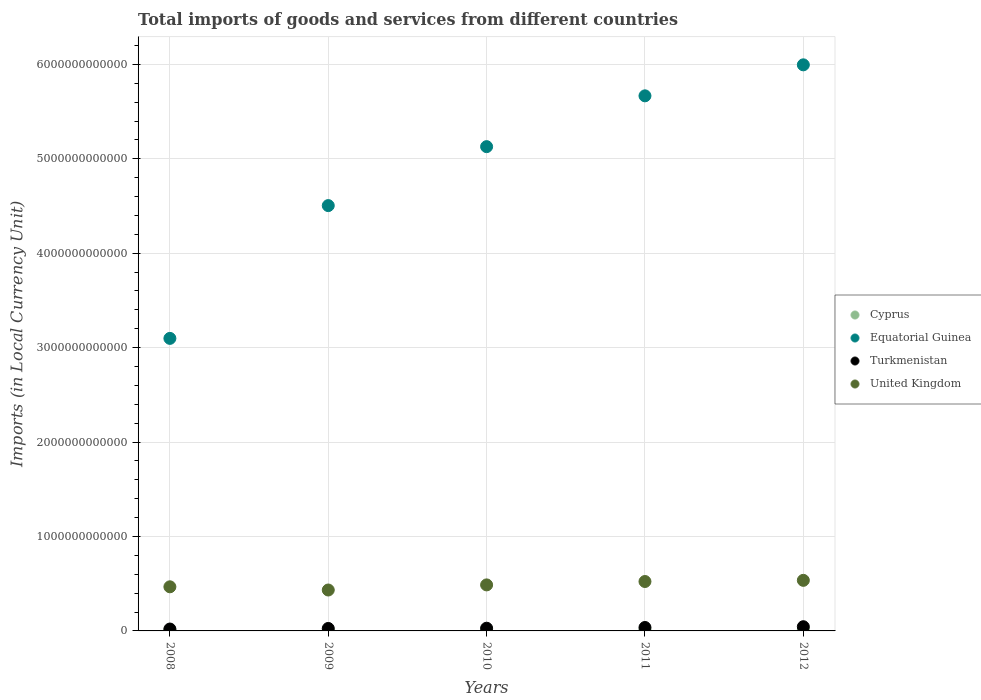What is the Amount of goods and services imports in Equatorial Guinea in 2010?
Provide a succinct answer. 5.13e+12. Across all years, what is the maximum Amount of goods and services imports in Equatorial Guinea?
Your answer should be compact. 6.00e+12. Across all years, what is the minimum Amount of goods and services imports in Cyprus?
Keep it short and to the point. 9.55e+09. In which year was the Amount of goods and services imports in Equatorial Guinea minimum?
Make the answer very short. 2008. What is the total Amount of goods and services imports in United Kingdom in the graph?
Your response must be concise. 2.45e+12. What is the difference between the Amount of goods and services imports in Cyprus in 2008 and that in 2011?
Offer a terse response. 1.12e+09. What is the difference between the Amount of goods and services imports in Equatorial Guinea in 2011 and the Amount of goods and services imports in Turkmenistan in 2012?
Make the answer very short. 5.62e+12. What is the average Amount of goods and services imports in Turkmenistan per year?
Offer a very short reply. 3.11e+1. In the year 2011, what is the difference between the Amount of goods and services imports in Equatorial Guinea and Amount of goods and services imports in United Kingdom?
Your answer should be compact. 5.14e+12. What is the ratio of the Amount of goods and services imports in Cyprus in 2008 to that in 2010?
Your response must be concise. 1.13. Is the Amount of goods and services imports in Turkmenistan in 2010 less than that in 2011?
Ensure brevity in your answer.  Yes. What is the difference between the highest and the second highest Amount of goods and services imports in Equatorial Guinea?
Your answer should be compact. 3.28e+11. What is the difference between the highest and the lowest Amount of goods and services imports in Turkmenistan?
Offer a very short reply. 2.45e+1. In how many years, is the Amount of goods and services imports in Equatorial Guinea greater than the average Amount of goods and services imports in Equatorial Guinea taken over all years?
Provide a succinct answer. 3. Is the sum of the Amount of goods and services imports in Equatorial Guinea in 2011 and 2012 greater than the maximum Amount of goods and services imports in United Kingdom across all years?
Give a very brief answer. Yes. Is it the case that in every year, the sum of the Amount of goods and services imports in Turkmenistan and Amount of goods and services imports in United Kingdom  is greater than the sum of Amount of goods and services imports in Cyprus and Amount of goods and services imports in Equatorial Guinea?
Your answer should be very brief. No. Is it the case that in every year, the sum of the Amount of goods and services imports in Cyprus and Amount of goods and services imports in Turkmenistan  is greater than the Amount of goods and services imports in United Kingdom?
Keep it short and to the point. No. Is the Amount of goods and services imports in Turkmenistan strictly greater than the Amount of goods and services imports in United Kingdom over the years?
Your answer should be very brief. No. Is the Amount of goods and services imports in Equatorial Guinea strictly less than the Amount of goods and services imports in Turkmenistan over the years?
Your answer should be compact. No. What is the difference between two consecutive major ticks on the Y-axis?
Provide a succinct answer. 1.00e+12. Where does the legend appear in the graph?
Your response must be concise. Center right. How many legend labels are there?
Provide a short and direct response. 4. What is the title of the graph?
Your response must be concise. Total imports of goods and services from different countries. Does "Ireland" appear as one of the legend labels in the graph?
Provide a short and direct response. No. What is the label or title of the Y-axis?
Offer a very short reply. Imports (in Local Currency Unit). What is the Imports (in Local Currency Unit) in Cyprus in 2008?
Give a very brief answer. 1.14e+1. What is the Imports (in Local Currency Unit) of Equatorial Guinea in 2008?
Provide a short and direct response. 3.10e+12. What is the Imports (in Local Currency Unit) of Turkmenistan in 2008?
Make the answer very short. 2.00e+1. What is the Imports (in Local Currency Unit) in United Kingdom in 2008?
Offer a terse response. 4.67e+11. What is the Imports (in Local Currency Unit) of Cyprus in 2009?
Keep it short and to the point. 9.55e+09. What is the Imports (in Local Currency Unit) in Equatorial Guinea in 2009?
Your answer should be compact. 4.50e+12. What is the Imports (in Local Currency Unit) of Turkmenistan in 2009?
Your answer should be compact. 2.61e+1. What is the Imports (in Local Currency Unit) in United Kingdom in 2009?
Make the answer very short. 4.33e+11. What is the Imports (in Local Currency Unit) of Cyprus in 2010?
Offer a very short reply. 1.02e+1. What is the Imports (in Local Currency Unit) of Equatorial Guinea in 2010?
Offer a terse response. 5.13e+12. What is the Imports (in Local Currency Unit) in Turkmenistan in 2010?
Make the answer very short. 2.86e+1. What is the Imports (in Local Currency Unit) of United Kingdom in 2010?
Your response must be concise. 4.87e+11. What is the Imports (in Local Currency Unit) of Cyprus in 2011?
Give a very brief answer. 1.03e+1. What is the Imports (in Local Currency Unit) of Equatorial Guinea in 2011?
Keep it short and to the point. 5.67e+12. What is the Imports (in Local Currency Unit) in Turkmenistan in 2011?
Offer a terse response. 3.63e+1. What is the Imports (in Local Currency Unit) of United Kingdom in 2011?
Offer a very short reply. 5.23e+11. What is the Imports (in Local Currency Unit) in Cyprus in 2012?
Make the answer very short. 1.00e+1. What is the Imports (in Local Currency Unit) of Equatorial Guinea in 2012?
Offer a very short reply. 6.00e+12. What is the Imports (in Local Currency Unit) of Turkmenistan in 2012?
Your answer should be very brief. 4.45e+1. What is the Imports (in Local Currency Unit) of United Kingdom in 2012?
Your answer should be very brief. 5.36e+11. Across all years, what is the maximum Imports (in Local Currency Unit) of Cyprus?
Give a very brief answer. 1.14e+1. Across all years, what is the maximum Imports (in Local Currency Unit) in Equatorial Guinea?
Keep it short and to the point. 6.00e+12. Across all years, what is the maximum Imports (in Local Currency Unit) of Turkmenistan?
Your answer should be compact. 4.45e+1. Across all years, what is the maximum Imports (in Local Currency Unit) in United Kingdom?
Your answer should be compact. 5.36e+11. Across all years, what is the minimum Imports (in Local Currency Unit) of Cyprus?
Provide a short and direct response. 9.55e+09. Across all years, what is the minimum Imports (in Local Currency Unit) of Equatorial Guinea?
Offer a very short reply. 3.10e+12. Across all years, what is the minimum Imports (in Local Currency Unit) of Turkmenistan?
Offer a terse response. 2.00e+1. Across all years, what is the minimum Imports (in Local Currency Unit) of United Kingdom?
Your response must be concise. 4.33e+11. What is the total Imports (in Local Currency Unit) in Cyprus in the graph?
Offer a very short reply. 5.15e+1. What is the total Imports (in Local Currency Unit) in Equatorial Guinea in the graph?
Offer a very short reply. 2.44e+13. What is the total Imports (in Local Currency Unit) of Turkmenistan in the graph?
Your answer should be very brief. 1.55e+11. What is the total Imports (in Local Currency Unit) of United Kingdom in the graph?
Ensure brevity in your answer.  2.45e+12. What is the difference between the Imports (in Local Currency Unit) in Cyprus in 2008 and that in 2009?
Provide a short and direct response. 1.89e+09. What is the difference between the Imports (in Local Currency Unit) of Equatorial Guinea in 2008 and that in 2009?
Your response must be concise. -1.41e+12. What is the difference between the Imports (in Local Currency Unit) of Turkmenistan in 2008 and that in 2009?
Your answer should be very brief. -6.09e+09. What is the difference between the Imports (in Local Currency Unit) of United Kingdom in 2008 and that in 2009?
Offer a terse response. 3.39e+1. What is the difference between the Imports (in Local Currency Unit) of Cyprus in 2008 and that in 2010?
Give a very brief answer. 1.28e+09. What is the difference between the Imports (in Local Currency Unit) in Equatorial Guinea in 2008 and that in 2010?
Your response must be concise. -2.03e+12. What is the difference between the Imports (in Local Currency Unit) of Turkmenistan in 2008 and that in 2010?
Provide a short and direct response. -8.65e+09. What is the difference between the Imports (in Local Currency Unit) in United Kingdom in 2008 and that in 2010?
Offer a very short reply. -2.02e+1. What is the difference between the Imports (in Local Currency Unit) of Cyprus in 2008 and that in 2011?
Make the answer very short. 1.12e+09. What is the difference between the Imports (in Local Currency Unit) of Equatorial Guinea in 2008 and that in 2011?
Keep it short and to the point. -2.57e+12. What is the difference between the Imports (in Local Currency Unit) in Turkmenistan in 2008 and that in 2011?
Your answer should be compact. -1.63e+1. What is the difference between the Imports (in Local Currency Unit) in United Kingdom in 2008 and that in 2011?
Your answer should be very brief. -5.60e+1. What is the difference between the Imports (in Local Currency Unit) in Cyprus in 2008 and that in 2012?
Keep it short and to the point. 1.41e+09. What is the difference between the Imports (in Local Currency Unit) of Equatorial Guinea in 2008 and that in 2012?
Your answer should be compact. -2.90e+12. What is the difference between the Imports (in Local Currency Unit) in Turkmenistan in 2008 and that in 2012?
Keep it short and to the point. -2.45e+1. What is the difference between the Imports (in Local Currency Unit) in United Kingdom in 2008 and that in 2012?
Ensure brevity in your answer.  -6.84e+1. What is the difference between the Imports (in Local Currency Unit) of Cyprus in 2009 and that in 2010?
Your answer should be compact. -6.08e+08. What is the difference between the Imports (in Local Currency Unit) in Equatorial Guinea in 2009 and that in 2010?
Ensure brevity in your answer.  -6.24e+11. What is the difference between the Imports (in Local Currency Unit) of Turkmenistan in 2009 and that in 2010?
Provide a succinct answer. -2.56e+09. What is the difference between the Imports (in Local Currency Unit) of United Kingdom in 2009 and that in 2010?
Keep it short and to the point. -5.41e+1. What is the difference between the Imports (in Local Currency Unit) of Cyprus in 2009 and that in 2011?
Your answer should be compact. -7.69e+08. What is the difference between the Imports (in Local Currency Unit) in Equatorial Guinea in 2009 and that in 2011?
Your response must be concise. -1.16e+12. What is the difference between the Imports (in Local Currency Unit) in Turkmenistan in 2009 and that in 2011?
Give a very brief answer. -1.02e+1. What is the difference between the Imports (in Local Currency Unit) in United Kingdom in 2009 and that in 2011?
Make the answer very short. -9.00e+1. What is the difference between the Imports (in Local Currency Unit) in Cyprus in 2009 and that in 2012?
Ensure brevity in your answer.  -4.78e+08. What is the difference between the Imports (in Local Currency Unit) in Equatorial Guinea in 2009 and that in 2012?
Provide a short and direct response. -1.49e+12. What is the difference between the Imports (in Local Currency Unit) of Turkmenistan in 2009 and that in 2012?
Provide a short and direct response. -1.84e+1. What is the difference between the Imports (in Local Currency Unit) in United Kingdom in 2009 and that in 2012?
Your answer should be very brief. -1.02e+11. What is the difference between the Imports (in Local Currency Unit) of Cyprus in 2010 and that in 2011?
Give a very brief answer. -1.61e+08. What is the difference between the Imports (in Local Currency Unit) in Equatorial Guinea in 2010 and that in 2011?
Provide a succinct answer. -5.38e+11. What is the difference between the Imports (in Local Currency Unit) in Turkmenistan in 2010 and that in 2011?
Give a very brief answer. -7.64e+09. What is the difference between the Imports (in Local Currency Unit) of United Kingdom in 2010 and that in 2011?
Your answer should be very brief. -3.59e+1. What is the difference between the Imports (in Local Currency Unit) of Cyprus in 2010 and that in 2012?
Ensure brevity in your answer.  1.30e+08. What is the difference between the Imports (in Local Currency Unit) of Equatorial Guinea in 2010 and that in 2012?
Provide a short and direct response. -8.66e+11. What is the difference between the Imports (in Local Currency Unit) in Turkmenistan in 2010 and that in 2012?
Keep it short and to the point. -1.59e+1. What is the difference between the Imports (in Local Currency Unit) of United Kingdom in 2010 and that in 2012?
Keep it short and to the point. -4.82e+1. What is the difference between the Imports (in Local Currency Unit) of Cyprus in 2011 and that in 2012?
Your response must be concise. 2.91e+08. What is the difference between the Imports (in Local Currency Unit) in Equatorial Guinea in 2011 and that in 2012?
Provide a succinct answer. -3.28e+11. What is the difference between the Imports (in Local Currency Unit) of Turkmenistan in 2011 and that in 2012?
Your answer should be very brief. -8.22e+09. What is the difference between the Imports (in Local Currency Unit) in United Kingdom in 2011 and that in 2012?
Provide a succinct answer. -1.23e+1. What is the difference between the Imports (in Local Currency Unit) of Cyprus in 2008 and the Imports (in Local Currency Unit) of Equatorial Guinea in 2009?
Your response must be concise. -4.49e+12. What is the difference between the Imports (in Local Currency Unit) of Cyprus in 2008 and the Imports (in Local Currency Unit) of Turkmenistan in 2009?
Provide a short and direct response. -1.46e+1. What is the difference between the Imports (in Local Currency Unit) of Cyprus in 2008 and the Imports (in Local Currency Unit) of United Kingdom in 2009?
Your answer should be compact. -4.22e+11. What is the difference between the Imports (in Local Currency Unit) in Equatorial Guinea in 2008 and the Imports (in Local Currency Unit) in Turkmenistan in 2009?
Provide a short and direct response. 3.07e+12. What is the difference between the Imports (in Local Currency Unit) of Equatorial Guinea in 2008 and the Imports (in Local Currency Unit) of United Kingdom in 2009?
Your response must be concise. 2.66e+12. What is the difference between the Imports (in Local Currency Unit) in Turkmenistan in 2008 and the Imports (in Local Currency Unit) in United Kingdom in 2009?
Offer a very short reply. -4.13e+11. What is the difference between the Imports (in Local Currency Unit) in Cyprus in 2008 and the Imports (in Local Currency Unit) in Equatorial Guinea in 2010?
Your response must be concise. -5.12e+12. What is the difference between the Imports (in Local Currency Unit) of Cyprus in 2008 and the Imports (in Local Currency Unit) of Turkmenistan in 2010?
Your answer should be very brief. -1.72e+1. What is the difference between the Imports (in Local Currency Unit) of Cyprus in 2008 and the Imports (in Local Currency Unit) of United Kingdom in 2010?
Provide a short and direct response. -4.76e+11. What is the difference between the Imports (in Local Currency Unit) in Equatorial Guinea in 2008 and the Imports (in Local Currency Unit) in Turkmenistan in 2010?
Your answer should be very brief. 3.07e+12. What is the difference between the Imports (in Local Currency Unit) in Equatorial Guinea in 2008 and the Imports (in Local Currency Unit) in United Kingdom in 2010?
Offer a terse response. 2.61e+12. What is the difference between the Imports (in Local Currency Unit) of Turkmenistan in 2008 and the Imports (in Local Currency Unit) of United Kingdom in 2010?
Your answer should be very brief. -4.67e+11. What is the difference between the Imports (in Local Currency Unit) in Cyprus in 2008 and the Imports (in Local Currency Unit) in Equatorial Guinea in 2011?
Your answer should be compact. -5.66e+12. What is the difference between the Imports (in Local Currency Unit) in Cyprus in 2008 and the Imports (in Local Currency Unit) in Turkmenistan in 2011?
Give a very brief answer. -2.48e+1. What is the difference between the Imports (in Local Currency Unit) in Cyprus in 2008 and the Imports (in Local Currency Unit) in United Kingdom in 2011?
Give a very brief answer. -5.12e+11. What is the difference between the Imports (in Local Currency Unit) of Equatorial Guinea in 2008 and the Imports (in Local Currency Unit) of Turkmenistan in 2011?
Offer a terse response. 3.06e+12. What is the difference between the Imports (in Local Currency Unit) in Equatorial Guinea in 2008 and the Imports (in Local Currency Unit) in United Kingdom in 2011?
Ensure brevity in your answer.  2.57e+12. What is the difference between the Imports (in Local Currency Unit) of Turkmenistan in 2008 and the Imports (in Local Currency Unit) of United Kingdom in 2011?
Give a very brief answer. -5.03e+11. What is the difference between the Imports (in Local Currency Unit) of Cyprus in 2008 and the Imports (in Local Currency Unit) of Equatorial Guinea in 2012?
Your response must be concise. -5.98e+12. What is the difference between the Imports (in Local Currency Unit) of Cyprus in 2008 and the Imports (in Local Currency Unit) of Turkmenistan in 2012?
Offer a terse response. -3.30e+1. What is the difference between the Imports (in Local Currency Unit) of Cyprus in 2008 and the Imports (in Local Currency Unit) of United Kingdom in 2012?
Your answer should be compact. -5.24e+11. What is the difference between the Imports (in Local Currency Unit) of Equatorial Guinea in 2008 and the Imports (in Local Currency Unit) of Turkmenistan in 2012?
Keep it short and to the point. 3.05e+12. What is the difference between the Imports (in Local Currency Unit) of Equatorial Guinea in 2008 and the Imports (in Local Currency Unit) of United Kingdom in 2012?
Make the answer very short. 2.56e+12. What is the difference between the Imports (in Local Currency Unit) of Turkmenistan in 2008 and the Imports (in Local Currency Unit) of United Kingdom in 2012?
Offer a terse response. -5.16e+11. What is the difference between the Imports (in Local Currency Unit) in Cyprus in 2009 and the Imports (in Local Currency Unit) in Equatorial Guinea in 2010?
Provide a succinct answer. -5.12e+12. What is the difference between the Imports (in Local Currency Unit) in Cyprus in 2009 and the Imports (in Local Currency Unit) in Turkmenistan in 2010?
Provide a short and direct response. -1.91e+1. What is the difference between the Imports (in Local Currency Unit) in Cyprus in 2009 and the Imports (in Local Currency Unit) in United Kingdom in 2010?
Your response must be concise. -4.78e+11. What is the difference between the Imports (in Local Currency Unit) of Equatorial Guinea in 2009 and the Imports (in Local Currency Unit) of Turkmenistan in 2010?
Ensure brevity in your answer.  4.48e+12. What is the difference between the Imports (in Local Currency Unit) in Equatorial Guinea in 2009 and the Imports (in Local Currency Unit) in United Kingdom in 2010?
Give a very brief answer. 4.02e+12. What is the difference between the Imports (in Local Currency Unit) in Turkmenistan in 2009 and the Imports (in Local Currency Unit) in United Kingdom in 2010?
Your answer should be compact. -4.61e+11. What is the difference between the Imports (in Local Currency Unit) of Cyprus in 2009 and the Imports (in Local Currency Unit) of Equatorial Guinea in 2011?
Give a very brief answer. -5.66e+12. What is the difference between the Imports (in Local Currency Unit) in Cyprus in 2009 and the Imports (in Local Currency Unit) in Turkmenistan in 2011?
Your answer should be very brief. -2.67e+1. What is the difference between the Imports (in Local Currency Unit) of Cyprus in 2009 and the Imports (in Local Currency Unit) of United Kingdom in 2011?
Ensure brevity in your answer.  -5.14e+11. What is the difference between the Imports (in Local Currency Unit) in Equatorial Guinea in 2009 and the Imports (in Local Currency Unit) in Turkmenistan in 2011?
Give a very brief answer. 4.47e+12. What is the difference between the Imports (in Local Currency Unit) of Equatorial Guinea in 2009 and the Imports (in Local Currency Unit) of United Kingdom in 2011?
Offer a terse response. 3.98e+12. What is the difference between the Imports (in Local Currency Unit) of Turkmenistan in 2009 and the Imports (in Local Currency Unit) of United Kingdom in 2011?
Provide a succinct answer. -4.97e+11. What is the difference between the Imports (in Local Currency Unit) in Cyprus in 2009 and the Imports (in Local Currency Unit) in Equatorial Guinea in 2012?
Provide a succinct answer. -5.99e+12. What is the difference between the Imports (in Local Currency Unit) of Cyprus in 2009 and the Imports (in Local Currency Unit) of Turkmenistan in 2012?
Give a very brief answer. -3.49e+1. What is the difference between the Imports (in Local Currency Unit) in Cyprus in 2009 and the Imports (in Local Currency Unit) in United Kingdom in 2012?
Your answer should be compact. -5.26e+11. What is the difference between the Imports (in Local Currency Unit) in Equatorial Guinea in 2009 and the Imports (in Local Currency Unit) in Turkmenistan in 2012?
Keep it short and to the point. 4.46e+12. What is the difference between the Imports (in Local Currency Unit) of Equatorial Guinea in 2009 and the Imports (in Local Currency Unit) of United Kingdom in 2012?
Your answer should be compact. 3.97e+12. What is the difference between the Imports (in Local Currency Unit) of Turkmenistan in 2009 and the Imports (in Local Currency Unit) of United Kingdom in 2012?
Your answer should be compact. -5.10e+11. What is the difference between the Imports (in Local Currency Unit) of Cyprus in 2010 and the Imports (in Local Currency Unit) of Equatorial Guinea in 2011?
Offer a terse response. -5.66e+12. What is the difference between the Imports (in Local Currency Unit) of Cyprus in 2010 and the Imports (in Local Currency Unit) of Turkmenistan in 2011?
Your response must be concise. -2.61e+1. What is the difference between the Imports (in Local Currency Unit) in Cyprus in 2010 and the Imports (in Local Currency Unit) in United Kingdom in 2011?
Your answer should be compact. -5.13e+11. What is the difference between the Imports (in Local Currency Unit) in Equatorial Guinea in 2010 and the Imports (in Local Currency Unit) in Turkmenistan in 2011?
Offer a very short reply. 5.09e+12. What is the difference between the Imports (in Local Currency Unit) of Equatorial Guinea in 2010 and the Imports (in Local Currency Unit) of United Kingdom in 2011?
Ensure brevity in your answer.  4.61e+12. What is the difference between the Imports (in Local Currency Unit) in Turkmenistan in 2010 and the Imports (in Local Currency Unit) in United Kingdom in 2011?
Give a very brief answer. -4.95e+11. What is the difference between the Imports (in Local Currency Unit) in Cyprus in 2010 and the Imports (in Local Currency Unit) in Equatorial Guinea in 2012?
Offer a terse response. -5.99e+12. What is the difference between the Imports (in Local Currency Unit) in Cyprus in 2010 and the Imports (in Local Currency Unit) in Turkmenistan in 2012?
Keep it short and to the point. -3.43e+1. What is the difference between the Imports (in Local Currency Unit) of Cyprus in 2010 and the Imports (in Local Currency Unit) of United Kingdom in 2012?
Keep it short and to the point. -5.25e+11. What is the difference between the Imports (in Local Currency Unit) of Equatorial Guinea in 2010 and the Imports (in Local Currency Unit) of Turkmenistan in 2012?
Keep it short and to the point. 5.08e+12. What is the difference between the Imports (in Local Currency Unit) in Equatorial Guinea in 2010 and the Imports (in Local Currency Unit) in United Kingdom in 2012?
Offer a terse response. 4.59e+12. What is the difference between the Imports (in Local Currency Unit) of Turkmenistan in 2010 and the Imports (in Local Currency Unit) of United Kingdom in 2012?
Give a very brief answer. -5.07e+11. What is the difference between the Imports (in Local Currency Unit) of Cyprus in 2011 and the Imports (in Local Currency Unit) of Equatorial Guinea in 2012?
Give a very brief answer. -5.98e+12. What is the difference between the Imports (in Local Currency Unit) in Cyprus in 2011 and the Imports (in Local Currency Unit) in Turkmenistan in 2012?
Offer a terse response. -3.42e+1. What is the difference between the Imports (in Local Currency Unit) in Cyprus in 2011 and the Imports (in Local Currency Unit) in United Kingdom in 2012?
Your response must be concise. -5.25e+11. What is the difference between the Imports (in Local Currency Unit) in Equatorial Guinea in 2011 and the Imports (in Local Currency Unit) in Turkmenistan in 2012?
Give a very brief answer. 5.62e+12. What is the difference between the Imports (in Local Currency Unit) of Equatorial Guinea in 2011 and the Imports (in Local Currency Unit) of United Kingdom in 2012?
Your answer should be compact. 5.13e+12. What is the difference between the Imports (in Local Currency Unit) of Turkmenistan in 2011 and the Imports (in Local Currency Unit) of United Kingdom in 2012?
Your answer should be compact. -4.99e+11. What is the average Imports (in Local Currency Unit) of Cyprus per year?
Your answer should be very brief. 1.03e+1. What is the average Imports (in Local Currency Unit) of Equatorial Guinea per year?
Your answer should be very brief. 4.88e+12. What is the average Imports (in Local Currency Unit) in Turkmenistan per year?
Offer a terse response. 3.11e+1. What is the average Imports (in Local Currency Unit) of United Kingdom per year?
Offer a very short reply. 4.89e+11. In the year 2008, what is the difference between the Imports (in Local Currency Unit) of Cyprus and Imports (in Local Currency Unit) of Equatorial Guinea?
Provide a succinct answer. -3.09e+12. In the year 2008, what is the difference between the Imports (in Local Currency Unit) of Cyprus and Imports (in Local Currency Unit) of Turkmenistan?
Keep it short and to the point. -8.53e+09. In the year 2008, what is the difference between the Imports (in Local Currency Unit) in Cyprus and Imports (in Local Currency Unit) in United Kingdom?
Ensure brevity in your answer.  -4.56e+11. In the year 2008, what is the difference between the Imports (in Local Currency Unit) of Equatorial Guinea and Imports (in Local Currency Unit) of Turkmenistan?
Provide a short and direct response. 3.08e+12. In the year 2008, what is the difference between the Imports (in Local Currency Unit) of Equatorial Guinea and Imports (in Local Currency Unit) of United Kingdom?
Make the answer very short. 2.63e+12. In the year 2008, what is the difference between the Imports (in Local Currency Unit) of Turkmenistan and Imports (in Local Currency Unit) of United Kingdom?
Offer a terse response. -4.47e+11. In the year 2009, what is the difference between the Imports (in Local Currency Unit) in Cyprus and Imports (in Local Currency Unit) in Equatorial Guinea?
Give a very brief answer. -4.49e+12. In the year 2009, what is the difference between the Imports (in Local Currency Unit) of Cyprus and Imports (in Local Currency Unit) of Turkmenistan?
Your answer should be very brief. -1.65e+1. In the year 2009, what is the difference between the Imports (in Local Currency Unit) of Cyprus and Imports (in Local Currency Unit) of United Kingdom?
Offer a terse response. -4.24e+11. In the year 2009, what is the difference between the Imports (in Local Currency Unit) in Equatorial Guinea and Imports (in Local Currency Unit) in Turkmenistan?
Your answer should be compact. 4.48e+12. In the year 2009, what is the difference between the Imports (in Local Currency Unit) of Equatorial Guinea and Imports (in Local Currency Unit) of United Kingdom?
Make the answer very short. 4.07e+12. In the year 2009, what is the difference between the Imports (in Local Currency Unit) of Turkmenistan and Imports (in Local Currency Unit) of United Kingdom?
Give a very brief answer. -4.07e+11. In the year 2010, what is the difference between the Imports (in Local Currency Unit) of Cyprus and Imports (in Local Currency Unit) of Equatorial Guinea?
Ensure brevity in your answer.  -5.12e+12. In the year 2010, what is the difference between the Imports (in Local Currency Unit) in Cyprus and Imports (in Local Currency Unit) in Turkmenistan?
Give a very brief answer. -1.85e+1. In the year 2010, what is the difference between the Imports (in Local Currency Unit) in Cyprus and Imports (in Local Currency Unit) in United Kingdom?
Offer a terse response. -4.77e+11. In the year 2010, what is the difference between the Imports (in Local Currency Unit) of Equatorial Guinea and Imports (in Local Currency Unit) of Turkmenistan?
Offer a very short reply. 5.10e+12. In the year 2010, what is the difference between the Imports (in Local Currency Unit) in Equatorial Guinea and Imports (in Local Currency Unit) in United Kingdom?
Provide a succinct answer. 4.64e+12. In the year 2010, what is the difference between the Imports (in Local Currency Unit) in Turkmenistan and Imports (in Local Currency Unit) in United Kingdom?
Your response must be concise. -4.59e+11. In the year 2011, what is the difference between the Imports (in Local Currency Unit) in Cyprus and Imports (in Local Currency Unit) in Equatorial Guinea?
Provide a short and direct response. -5.66e+12. In the year 2011, what is the difference between the Imports (in Local Currency Unit) of Cyprus and Imports (in Local Currency Unit) of Turkmenistan?
Your response must be concise. -2.59e+1. In the year 2011, what is the difference between the Imports (in Local Currency Unit) of Cyprus and Imports (in Local Currency Unit) of United Kingdom?
Ensure brevity in your answer.  -5.13e+11. In the year 2011, what is the difference between the Imports (in Local Currency Unit) of Equatorial Guinea and Imports (in Local Currency Unit) of Turkmenistan?
Offer a very short reply. 5.63e+12. In the year 2011, what is the difference between the Imports (in Local Currency Unit) in Equatorial Guinea and Imports (in Local Currency Unit) in United Kingdom?
Make the answer very short. 5.14e+12. In the year 2011, what is the difference between the Imports (in Local Currency Unit) of Turkmenistan and Imports (in Local Currency Unit) of United Kingdom?
Provide a short and direct response. -4.87e+11. In the year 2012, what is the difference between the Imports (in Local Currency Unit) in Cyprus and Imports (in Local Currency Unit) in Equatorial Guinea?
Offer a very short reply. -5.99e+12. In the year 2012, what is the difference between the Imports (in Local Currency Unit) of Cyprus and Imports (in Local Currency Unit) of Turkmenistan?
Provide a short and direct response. -3.45e+1. In the year 2012, what is the difference between the Imports (in Local Currency Unit) of Cyprus and Imports (in Local Currency Unit) of United Kingdom?
Ensure brevity in your answer.  -5.26e+11. In the year 2012, what is the difference between the Imports (in Local Currency Unit) of Equatorial Guinea and Imports (in Local Currency Unit) of Turkmenistan?
Ensure brevity in your answer.  5.95e+12. In the year 2012, what is the difference between the Imports (in Local Currency Unit) of Equatorial Guinea and Imports (in Local Currency Unit) of United Kingdom?
Your response must be concise. 5.46e+12. In the year 2012, what is the difference between the Imports (in Local Currency Unit) of Turkmenistan and Imports (in Local Currency Unit) of United Kingdom?
Ensure brevity in your answer.  -4.91e+11. What is the ratio of the Imports (in Local Currency Unit) of Cyprus in 2008 to that in 2009?
Your answer should be compact. 1.2. What is the ratio of the Imports (in Local Currency Unit) in Equatorial Guinea in 2008 to that in 2009?
Your answer should be very brief. 0.69. What is the ratio of the Imports (in Local Currency Unit) of Turkmenistan in 2008 to that in 2009?
Your answer should be compact. 0.77. What is the ratio of the Imports (in Local Currency Unit) in United Kingdom in 2008 to that in 2009?
Ensure brevity in your answer.  1.08. What is the ratio of the Imports (in Local Currency Unit) in Cyprus in 2008 to that in 2010?
Offer a very short reply. 1.13. What is the ratio of the Imports (in Local Currency Unit) of Equatorial Guinea in 2008 to that in 2010?
Ensure brevity in your answer.  0.6. What is the ratio of the Imports (in Local Currency Unit) of Turkmenistan in 2008 to that in 2010?
Your response must be concise. 0.7. What is the ratio of the Imports (in Local Currency Unit) of United Kingdom in 2008 to that in 2010?
Provide a succinct answer. 0.96. What is the ratio of the Imports (in Local Currency Unit) in Cyprus in 2008 to that in 2011?
Offer a very short reply. 1.11. What is the ratio of the Imports (in Local Currency Unit) in Equatorial Guinea in 2008 to that in 2011?
Offer a terse response. 0.55. What is the ratio of the Imports (in Local Currency Unit) of Turkmenistan in 2008 to that in 2011?
Your answer should be very brief. 0.55. What is the ratio of the Imports (in Local Currency Unit) of United Kingdom in 2008 to that in 2011?
Offer a terse response. 0.89. What is the ratio of the Imports (in Local Currency Unit) in Cyprus in 2008 to that in 2012?
Keep it short and to the point. 1.14. What is the ratio of the Imports (in Local Currency Unit) of Equatorial Guinea in 2008 to that in 2012?
Make the answer very short. 0.52. What is the ratio of the Imports (in Local Currency Unit) of Turkmenistan in 2008 to that in 2012?
Offer a terse response. 0.45. What is the ratio of the Imports (in Local Currency Unit) of United Kingdom in 2008 to that in 2012?
Your answer should be very brief. 0.87. What is the ratio of the Imports (in Local Currency Unit) in Cyprus in 2009 to that in 2010?
Offer a terse response. 0.94. What is the ratio of the Imports (in Local Currency Unit) in Equatorial Guinea in 2009 to that in 2010?
Keep it short and to the point. 0.88. What is the ratio of the Imports (in Local Currency Unit) of Turkmenistan in 2009 to that in 2010?
Keep it short and to the point. 0.91. What is the ratio of the Imports (in Local Currency Unit) in United Kingdom in 2009 to that in 2010?
Your response must be concise. 0.89. What is the ratio of the Imports (in Local Currency Unit) of Cyprus in 2009 to that in 2011?
Give a very brief answer. 0.93. What is the ratio of the Imports (in Local Currency Unit) of Equatorial Guinea in 2009 to that in 2011?
Ensure brevity in your answer.  0.79. What is the ratio of the Imports (in Local Currency Unit) of Turkmenistan in 2009 to that in 2011?
Keep it short and to the point. 0.72. What is the ratio of the Imports (in Local Currency Unit) in United Kingdom in 2009 to that in 2011?
Provide a succinct answer. 0.83. What is the ratio of the Imports (in Local Currency Unit) of Cyprus in 2009 to that in 2012?
Give a very brief answer. 0.95. What is the ratio of the Imports (in Local Currency Unit) in Equatorial Guinea in 2009 to that in 2012?
Give a very brief answer. 0.75. What is the ratio of the Imports (in Local Currency Unit) in Turkmenistan in 2009 to that in 2012?
Provide a short and direct response. 0.59. What is the ratio of the Imports (in Local Currency Unit) of United Kingdom in 2009 to that in 2012?
Keep it short and to the point. 0.81. What is the ratio of the Imports (in Local Currency Unit) in Cyprus in 2010 to that in 2011?
Make the answer very short. 0.98. What is the ratio of the Imports (in Local Currency Unit) in Equatorial Guinea in 2010 to that in 2011?
Your answer should be very brief. 0.91. What is the ratio of the Imports (in Local Currency Unit) of Turkmenistan in 2010 to that in 2011?
Provide a succinct answer. 0.79. What is the ratio of the Imports (in Local Currency Unit) in United Kingdom in 2010 to that in 2011?
Your answer should be very brief. 0.93. What is the ratio of the Imports (in Local Currency Unit) of Cyprus in 2010 to that in 2012?
Your answer should be compact. 1.01. What is the ratio of the Imports (in Local Currency Unit) in Equatorial Guinea in 2010 to that in 2012?
Make the answer very short. 0.86. What is the ratio of the Imports (in Local Currency Unit) in Turkmenistan in 2010 to that in 2012?
Your response must be concise. 0.64. What is the ratio of the Imports (in Local Currency Unit) in United Kingdom in 2010 to that in 2012?
Keep it short and to the point. 0.91. What is the ratio of the Imports (in Local Currency Unit) of Equatorial Guinea in 2011 to that in 2012?
Provide a short and direct response. 0.95. What is the ratio of the Imports (in Local Currency Unit) in Turkmenistan in 2011 to that in 2012?
Your answer should be very brief. 0.82. What is the difference between the highest and the second highest Imports (in Local Currency Unit) of Cyprus?
Your answer should be very brief. 1.12e+09. What is the difference between the highest and the second highest Imports (in Local Currency Unit) of Equatorial Guinea?
Give a very brief answer. 3.28e+11. What is the difference between the highest and the second highest Imports (in Local Currency Unit) in Turkmenistan?
Offer a terse response. 8.22e+09. What is the difference between the highest and the second highest Imports (in Local Currency Unit) of United Kingdom?
Your answer should be very brief. 1.23e+1. What is the difference between the highest and the lowest Imports (in Local Currency Unit) in Cyprus?
Give a very brief answer. 1.89e+09. What is the difference between the highest and the lowest Imports (in Local Currency Unit) in Equatorial Guinea?
Provide a short and direct response. 2.90e+12. What is the difference between the highest and the lowest Imports (in Local Currency Unit) of Turkmenistan?
Keep it short and to the point. 2.45e+1. What is the difference between the highest and the lowest Imports (in Local Currency Unit) in United Kingdom?
Keep it short and to the point. 1.02e+11. 